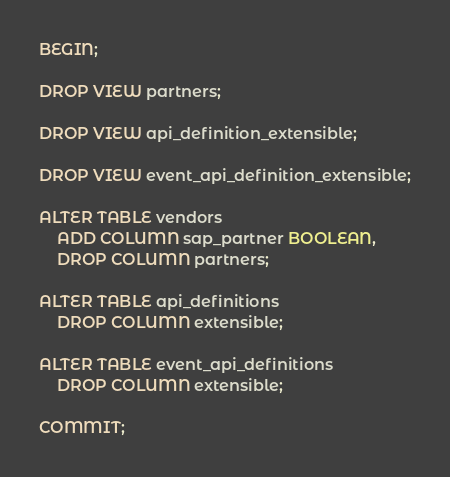<code> <loc_0><loc_0><loc_500><loc_500><_SQL_>BEGIN;

DROP VIEW partners;

DROP VIEW api_definition_extensible;

DROP VIEW event_api_definition_extensible;

ALTER TABLE vendors
    ADD COLUMN sap_partner BOOLEAN,
    DROP COLUMN partners;

ALTER TABLE api_definitions
    DROP COLUMN extensible;

ALTER TABLE event_api_definitions
    DROP COLUMN extensible;

COMMIT;
</code> 